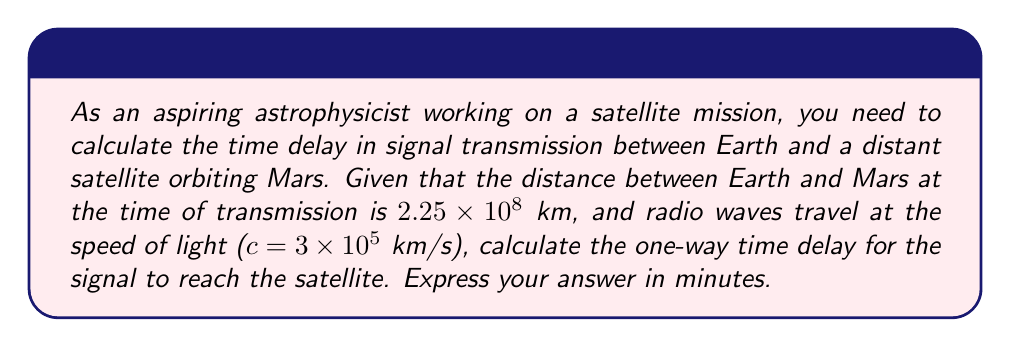Show me your answer to this math problem. To solve this problem, we need to use the fundamental equation relating distance, speed, and time:

$$\text{Time} = \frac{\text{Distance}}{\text{Speed}}$$

We are given:
- Distance ($d$) = $2.25 \times 10^8$ km
- Speed ($c$) = $3 \times 10^5$ km/s

Let's calculate the time in seconds:

$$t = \frac{d}{c} = \frac{2.25 \times 10^8 \text{ km}}{3 \times 10^5 \text{ km/s}}$$

Simplifying:

$$t = \frac{2.25}{3} \times 10^3 \text{ s} = 0.75 \times 10^3 \text{ s} = 750 \text{ s}$$

Now, we need to convert this to minutes. We know that 1 minute = 60 seconds, so:

$$t_{\text{minutes}} = \frac{750 \text{ s}}{60 \text{ s/min}} = 12.5 \text{ minutes}$$

Therefore, the one-way time delay for the signal to reach the satellite orbiting Mars is 12.5 minutes.
Answer: $12.5$ minutes 